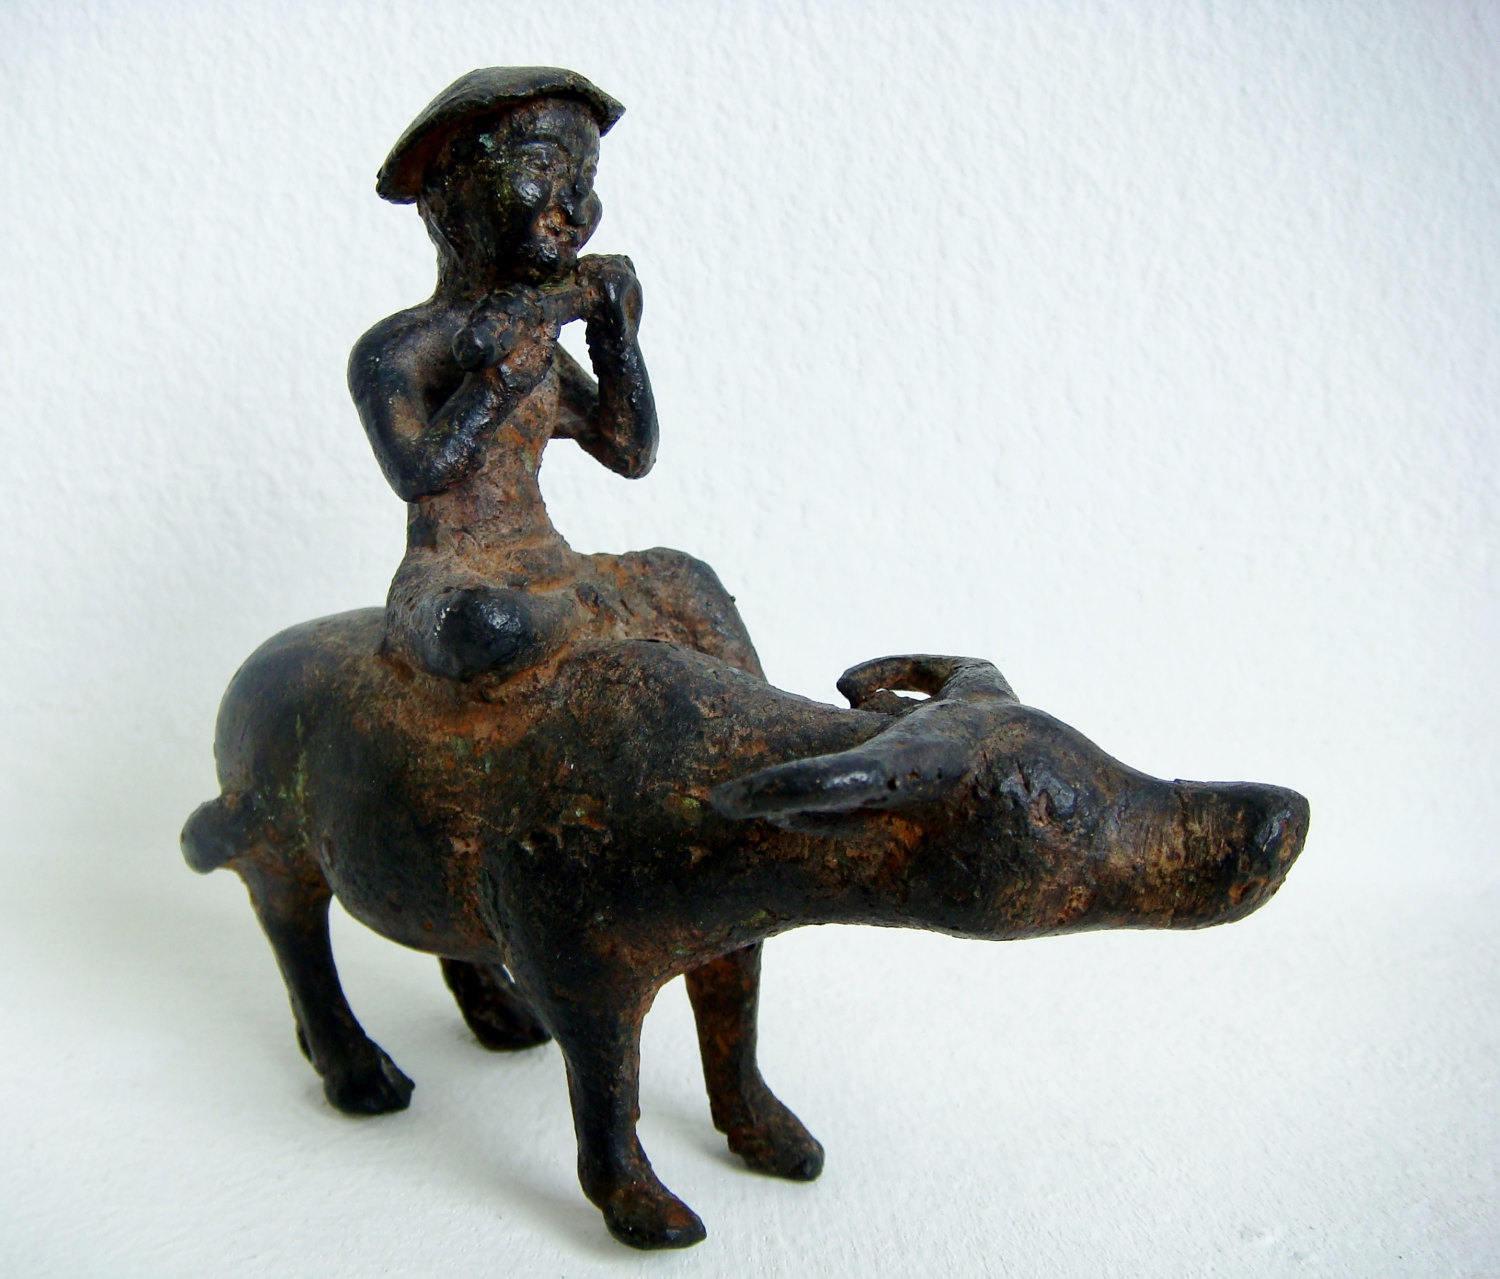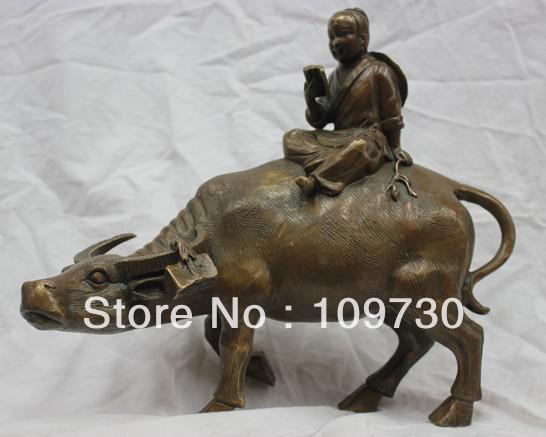The first image is the image on the left, the second image is the image on the right. For the images shown, is this caption "Each image shows at least one figure on the back of a water buffalo with its head extending forward so its horns are parallel with the ground." true? Answer yes or no. Yes. 